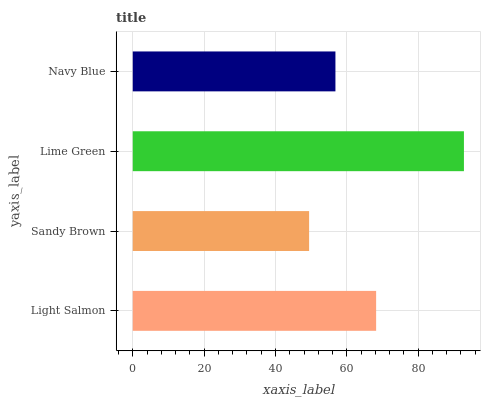Is Sandy Brown the minimum?
Answer yes or no. Yes. Is Lime Green the maximum?
Answer yes or no. Yes. Is Lime Green the minimum?
Answer yes or no. No. Is Sandy Brown the maximum?
Answer yes or no. No. Is Lime Green greater than Sandy Brown?
Answer yes or no. Yes. Is Sandy Brown less than Lime Green?
Answer yes or no. Yes. Is Sandy Brown greater than Lime Green?
Answer yes or no. No. Is Lime Green less than Sandy Brown?
Answer yes or no. No. Is Light Salmon the high median?
Answer yes or no. Yes. Is Navy Blue the low median?
Answer yes or no. Yes. Is Navy Blue the high median?
Answer yes or no. No. Is Lime Green the low median?
Answer yes or no. No. 